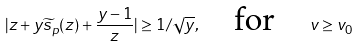<formula> <loc_0><loc_0><loc_500><loc_500>| z + y \widetilde { s } _ { p } ( z ) + \frac { y - 1 } z | \geq 1 / \sqrt { y } , \quad \text {for} \quad v \geq v _ { 0 }</formula> 